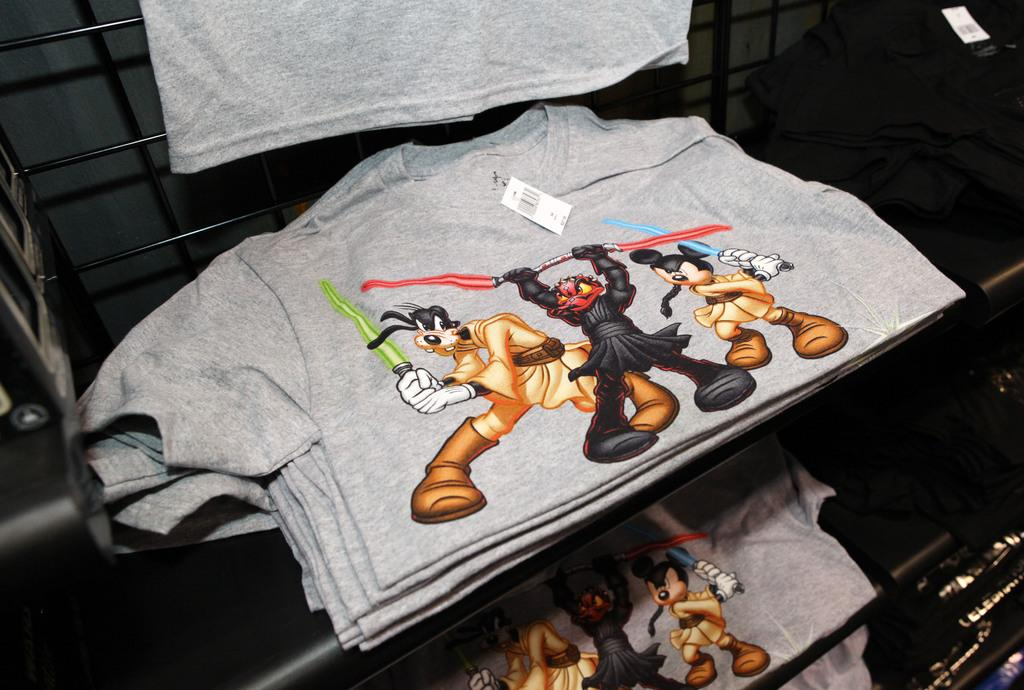What type of clothing is visible in the image? There are grey t-shirts in the image. How are the t-shirts arranged in the image? The t-shirts are on racks in the image. What design can be seen on the t-shirts? The t-shirts have cartoon prints. Are there any slaves or plantations visible in the image? No, there are no slaves or plantations present in the image. What type of pets can be seen on the t-shirts in the image? There are no pets visible on the t-shirts in the image; they have cartoon prints. 